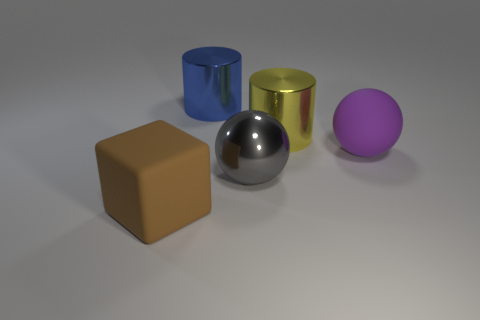Add 1 big yellow shiny objects. How many objects exist? 6 Subtract all gray spheres. Subtract all gray cubes. How many spheres are left? 1 Subtract all gray cylinders. How many gray cubes are left? 0 Subtract all big cyan matte blocks. Subtract all big rubber balls. How many objects are left? 4 Add 5 large purple rubber spheres. How many large purple rubber spheres are left? 6 Add 1 big rubber blocks. How many big rubber blocks exist? 2 Subtract 0 blue blocks. How many objects are left? 5 Subtract all blocks. How many objects are left? 4 Subtract 2 cylinders. How many cylinders are left? 0 